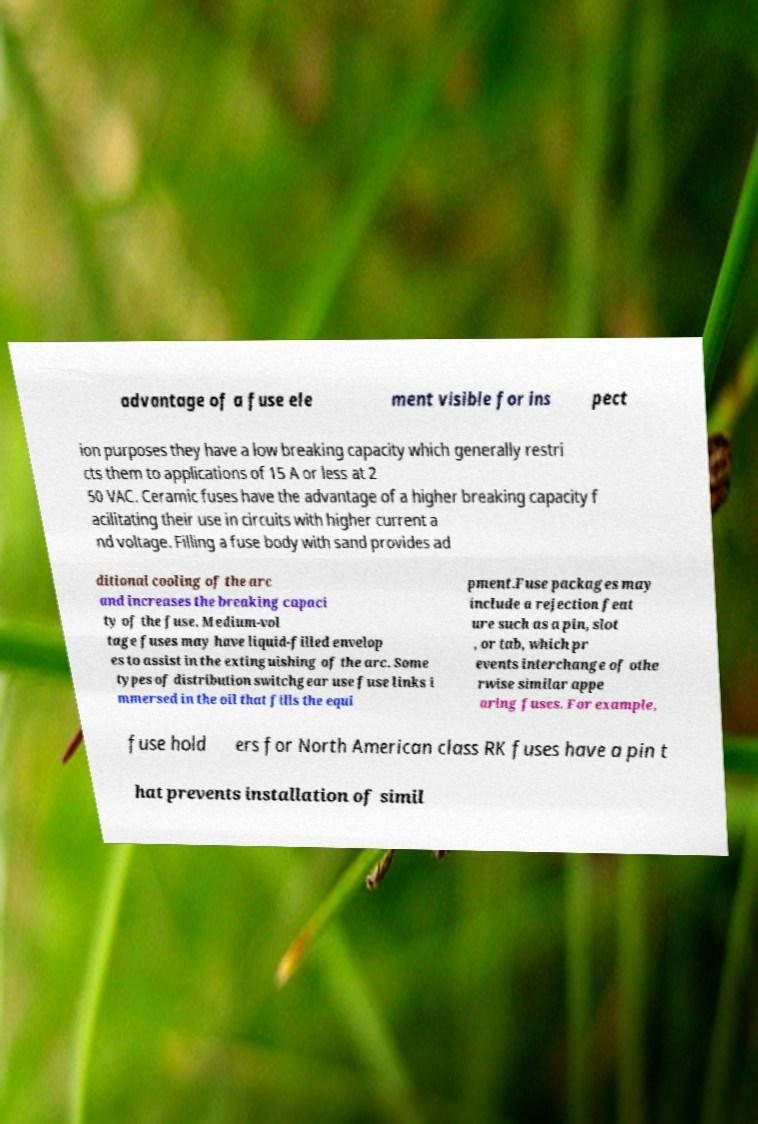What messages or text are displayed in this image? I need them in a readable, typed format. advantage of a fuse ele ment visible for ins pect ion purposes they have a low breaking capacity which generally restri cts them to applications of 15 A or less at 2 50 VAC. Ceramic fuses have the advantage of a higher breaking capacity f acilitating their use in circuits with higher current a nd voltage. Filling a fuse body with sand provides ad ditional cooling of the arc and increases the breaking capaci ty of the fuse. Medium-vol tage fuses may have liquid-filled envelop es to assist in the extinguishing of the arc. Some types of distribution switchgear use fuse links i mmersed in the oil that fills the equi pment.Fuse packages may include a rejection feat ure such as a pin, slot , or tab, which pr events interchange of othe rwise similar appe aring fuses. For example, fuse hold ers for North American class RK fuses have a pin t hat prevents installation of simil 